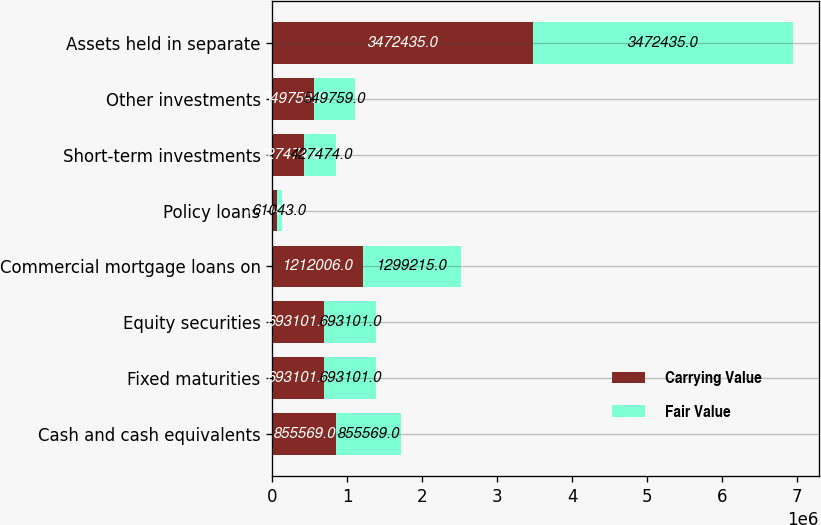Convert chart to OTSL. <chart><loc_0><loc_0><loc_500><loc_500><stacked_bar_chart><ecel><fcel>Cash and cash equivalents<fcel>Fixed maturities<fcel>Equity securities<fcel>Commercial mortgage loans on<fcel>Policy loans<fcel>Short-term investments<fcel>Other investments<fcel>Assets held in separate<nl><fcel>Carrying Value<fcel>855569<fcel>693101<fcel>693101<fcel>1.21201e+06<fcel>61043<fcel>427474<fcel>549759<fcel>3.47244e+06<nl><fcel>Fair Value<fcel>855569<fcel>693101<fcel>693101<fcel>1.29922e+06<fcel>61043<fcel>427474<fcel>549759<fcel>3.47244e+06<nl></chart> 